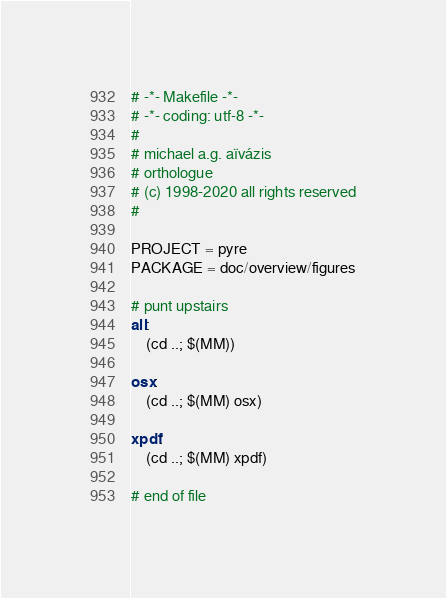<code> <loc_0><loc_0><loc_500><loc_500><_ObjectiveC_># -*- Makefile -*-
# -*- coding: utf-8 -*-
#
# michael a.g. aïvázis
# orthologue
# (c) 1998-2020 all rights reserved
#

PROJECT = pyre
PACKAGE = doc/overview/figures

# punt upstairs
all:
	(cd ..; $(MM))

osx:
	(cd ..; $(MM) osx)

xpdf:
	(cd ..; $(MM) xpdf)

# end of file
</code> 